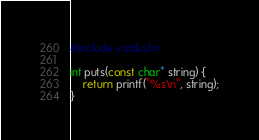<code> <loc_0><loc_0><loc_500><loc_500><_C_>#include <stdio.h>

int puts(const char* string) {
    return printf("%s\n", string);
}
</code> 